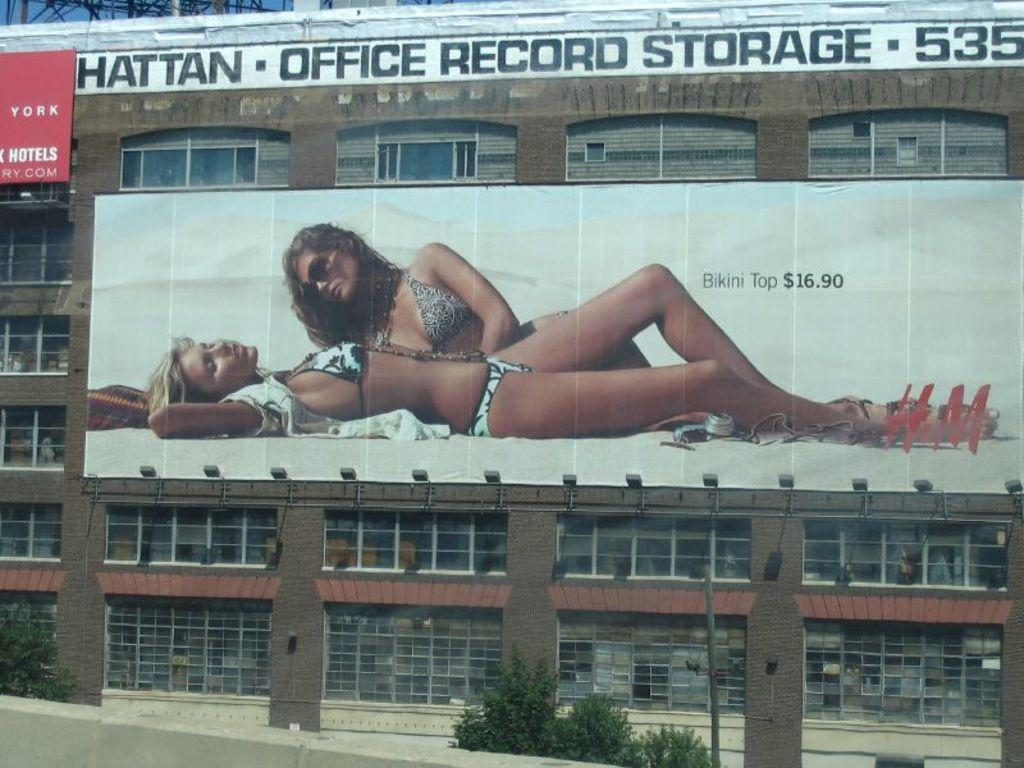<image>
Relay a brief, clear account of the picture shown. A large building with a billboard ad for bikini tops for $16.90. 